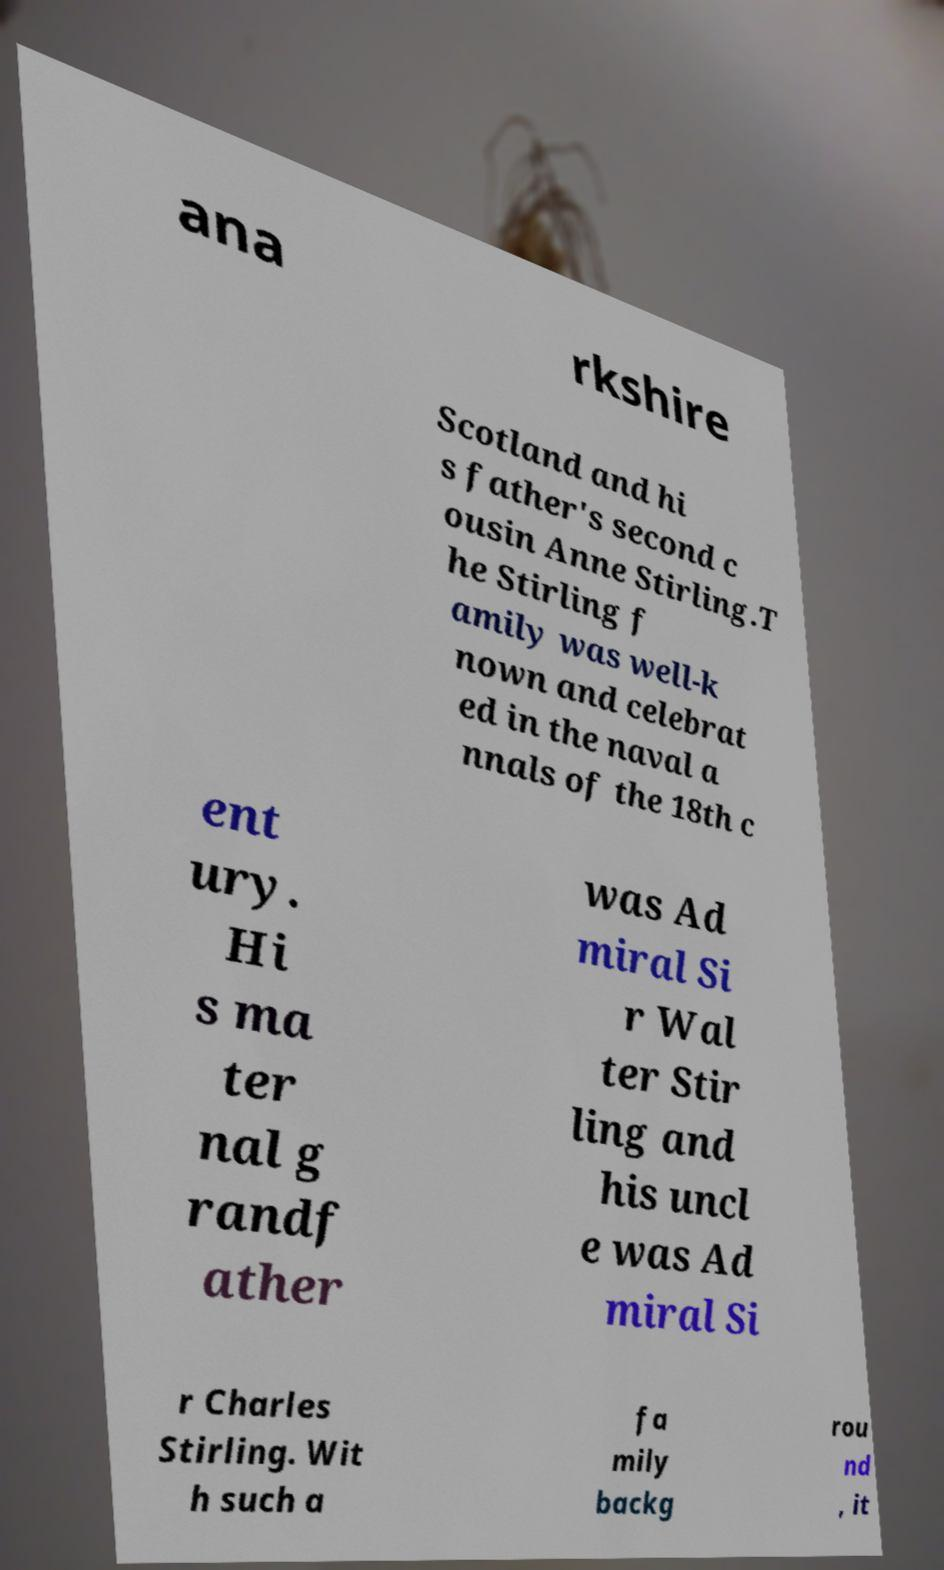Can you read and provide the text displayed in the image?This photo seems to have some interesting text. Can you extract and type it out for me? ana rkshire Scotland and hi s father's second c ousin Anne Stirling.T he Stirling f amily was well-k nown and celebrat ed in the naval a nnals of the 18th c ent ury. Hi s ma ter nal g randf ather was Ad miral Si r Wal ter Stir ling and his uncl e was Ad miral Si r Charles Stirling. Wit h such a fa mily backg rou nd , it 